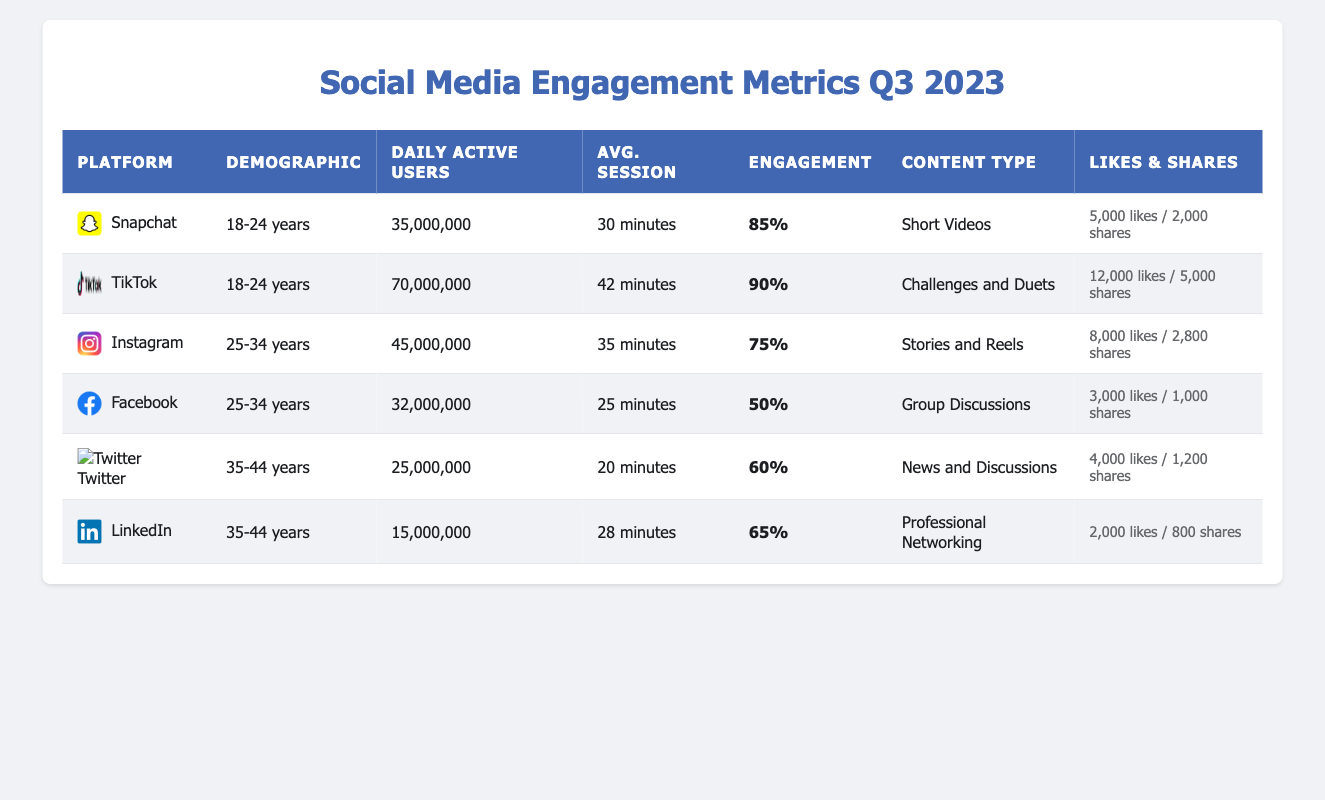What is the engagement rate for TikTok among the 18-24 age demographic? The table shows the engagement rate for TikTok listed under the 18-24 years demographic as 90%.
Answer: 90% Which platform has the highest average daily active users for the 25-34 age group? In the table, Instagram shows 45,000,000 average daily active users, while Facebook shows 32,000,000. Instagram has the highest among the two.
Answer: Instagram What is the average session duration for users aged 35-44 on LinkedIn? The average session duration for LinkedIn is 28 minutes as listed in the table under the 35-44 years demographic.
Answer: 28 minutes How many total likes were given for posts across all platforms for the 18-24 age group? For Snapchat, likes per post are 5,000 multiplied by the average daily active users (35,000,000), resulting in 175,000,000, and for TikTok, 12,000 multiplied by 70,000,000 gives 840,000,000. The total is 175,000,000 + 840,000,000 = 1,015,000,000.
Answer: 1,015,000,000 Is the average session duration for Facebook higher than for Twitter? The session duration for Facebook is 25 minutes, while for Twitter, it is only 20 minutes. Therefore, the average session duration for Facebook is indeed higher than for Twitter.
Answer: Yes What percentage of users engage with content on Instagram compared to TikTok? Engagement on Instagram is 75%, while it's 90% on TikTok. Comparing these, TikTok has a higher engagement percentage than Instagram by 15%.
Answer: TikTok has 15% higher engagement How many shares does the content generated by users aged 25-34 receive on average across Instagram and Facebook? On Instagram, users receive 2,800 shares per post, and on Facebook, 1,000 shares per post. Adding these, we get a total of 2,800 + 1,000 = 3,800 shares, which is the average across the two platforms for that demographic.
Answer: 3,800 shares What is the total number of daily active users for platforms targeting the 35-44 years demographic? For Twitter, there are 25,000,000 daily active users, and for LinkedIn, there are 15,000,000. Therefore, total daily active users for that demographic is 25,000,000 + 15,000,000 = 40,000,000.
Answer: 40,000,000 Which platform has the lowest engagement rate among users aged 25-34? According to the table, Facebook has an engagement rate of 50%, which is less than Instagram's 75%. Therefore, Facebook has the lowest engagement rate among platforms for that age group.
Answer: Facebook 